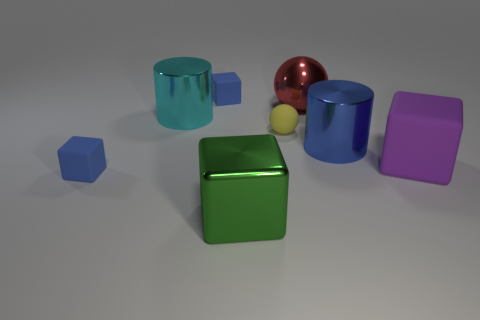Are there more blue matte things on the right side of the red metal ball than small blocks to the right of the large matte cube?
Provide a succinct answer. No. How many other objects are the same shape as the yellow thing?
Give a very brief answer. 1. Are there any big green blocks on the left side of the small object in front of the tiny yellow matte ball?
Offer a very short reply. No. What number of blue things are there?
Offer a very short reply. 3. Is the color of the small sphere the same as the shiny cylinder in front of the small yellow thing?
Provide a short and direct response. No. Is the number of blue cylinders greater than the number of tiny cyan metallic balls?
Give a very brief answer. Yes. Is there anything else of the same color as the shiny ball?
Offer a very short reply. No. What number of other objects are the same size as the green block?
Offer a terse response. 4. What is the thing in front of the blue rubber block that is in front of the cylinder right of the big shiny cube made of?
Offer a terse response. Metal. Do the small ball and the blue thing on the right side of the big green shiny block have the same material?
Your response must be concise. No. 